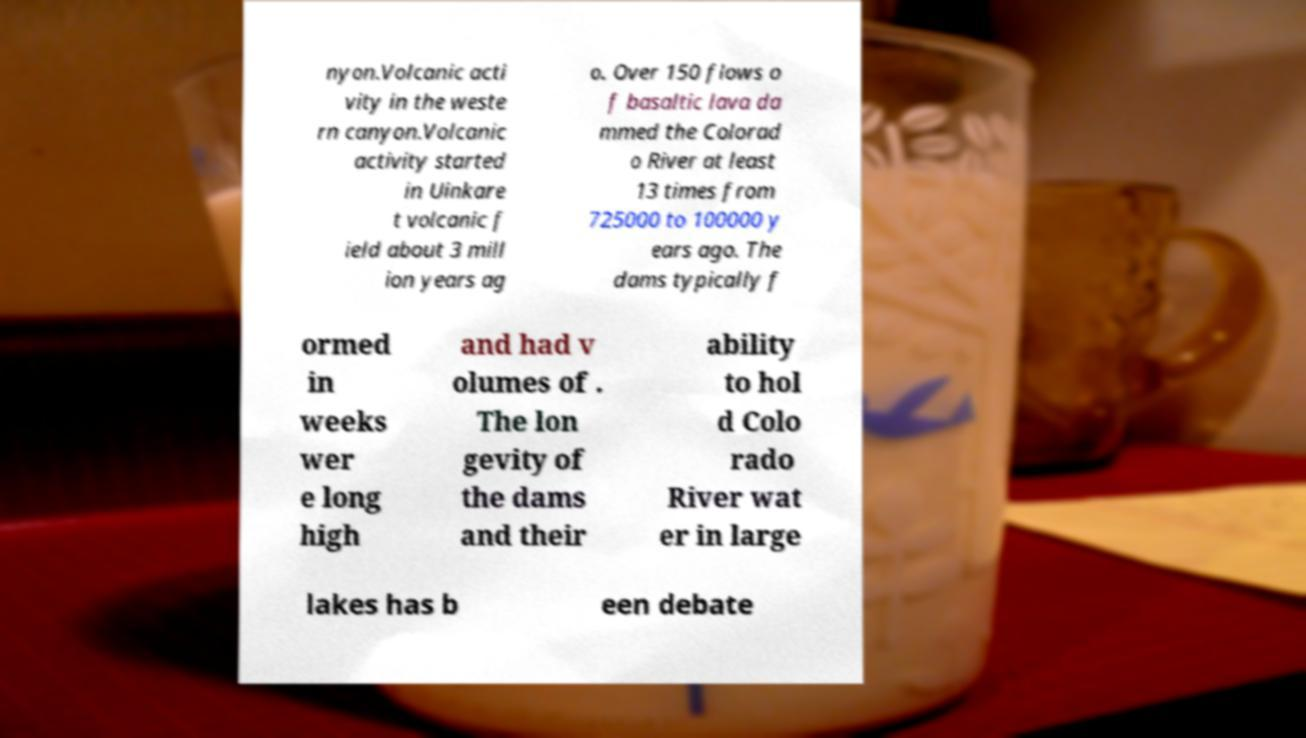Can you accurately transcribe the text from the provided image for me? nyon.Volcanic acti vity in the weste rn canyon.Volcanic activity started in Uinkare t volcanic f ield about 3 mill ion years ag o. Over 150 flows o f basaltic lava da mmed the Colorad o River at least 13 times from 725000 to 100000 y ears ago. The dams typically f ormed in weeks wer e long high and had v olumes of . The lon gevity of the dams and their ability to hol d Colo rado River wat er in large lakes has b een debate 